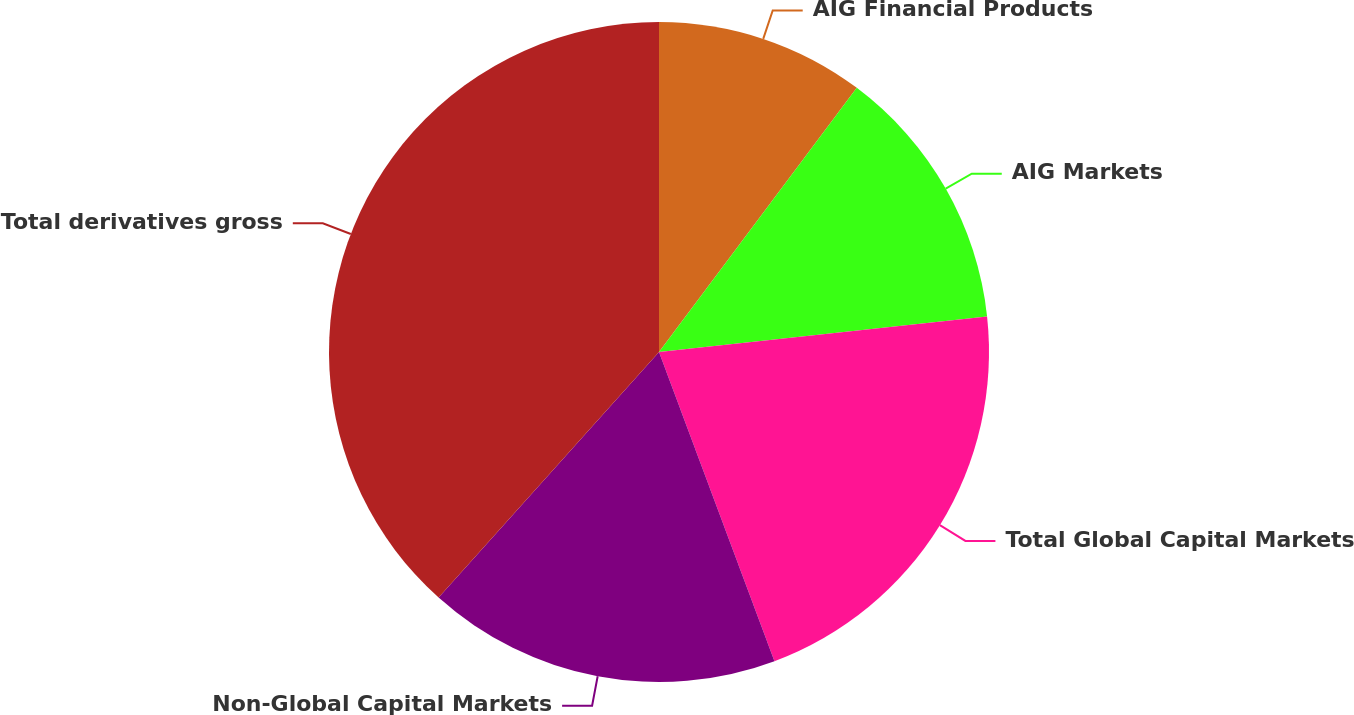<chart> <loc_0><loc_0><loc_500><loc_500><pie_chart><fcel>AIG Financial Products<fcel>AIG Markets<fcel>Total Global Capital Markets<fcel>Non-Global Capital Markets<fcel>Total derivatives gross<nl><fcel>10.23%<fcel>13.05%<fcel>21.03%<fcel>17.33%<fcel>38.36%<nl></chart> 